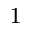<formula> <loc_0><loc_0><loc_500><loc_500>_ { 1 }</formula> 